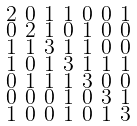Convert formula to latex. <formula><loc_0><loc_0><loc_500><loc_500>\begin{smallmatrix} 2 & 0 & 1 & 1 & 0 & 0 & 1 \\ 0 & 2 & 1 & 0 & 1 & 0 & 0 \\ 1 & 1 & 3 & 1 & 1 & 0 & 0 \\ 1 & 0 & 1 & 3 & 1 & 1 & 1 \\ 0 & 1 & 1 & 1 & 3 & 0 & 0 \\ 0 & 0 & 0 & 1 & 0 & 3 & 1 \\ 1 & 0 & 0 & 1 & 0 & 1 & 3 \end{smallmatrix}</formula> 